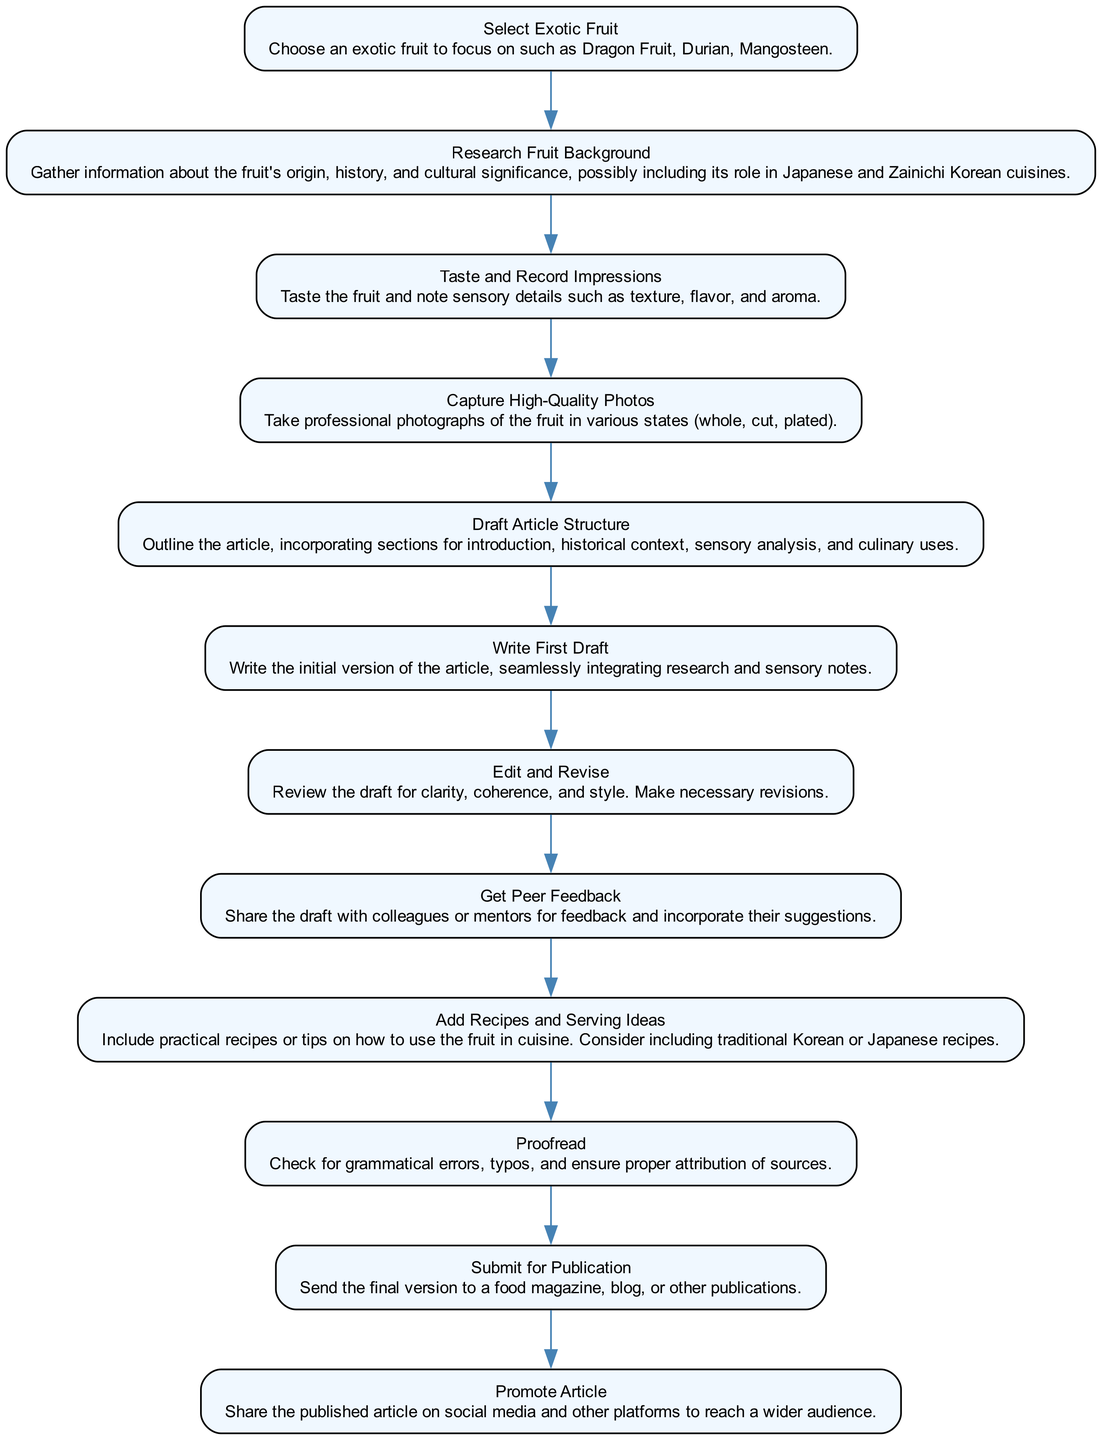What is the first step in the flowchart? The first step listed in the flowchart is "Select Exotic Fruit," indicating it is the starting point of the process for writing a food article.
Answer: Select Exotic Fruit How many total steps are there in the flowchart? By counting all the elements in the flowchart, we can see there are twelve distinct steps leading to the final goal, which gives us a total of twelve steps.
Answer: Twelve What follows after "Capture High-Quality Photos"? The flowchart indicates that after "Capture High-Quality Photos," the next step is "Draft Article Structure," showing a sequential progression in the writing process.
Answer: Draft Article Structure Which step includes the incorporation of cultural elements? The step "Research Fruit Background" mentions gathering information about the fruit's origin, history, and cultural significance, which highlights the importance of cultural context in the article.
Answer: Research Fruit Background What is the last activity in the flowchart? The final activity in the flowchart is "Promote Article," indicating the process concludes with sharing the published work on social media and other platforms.
Answer: Promote Article In how many steps is peer feedback involved? Peer feedback is involved in step eight, which explicitly states to "Get Peer Feedback" after completing the draft, showing that it is a singular step in the overall process.
Answer: One What is the relationship between "Write First Draft" and "Edit and Revise"? The relationship is sequential; "Write First Draft" leads to "Edit and Revise," as editing follows drafting in the typical writing process.
Answer: Sequential Which step specifically focuses on adding practical culinary content? The step "Add Recipes and Serving Ideas" is dedicated to including practical recipes or tips on how to use the exotic fruit, showcasing its culinary application.
Answer: Add Recipes and Serving Ideas 